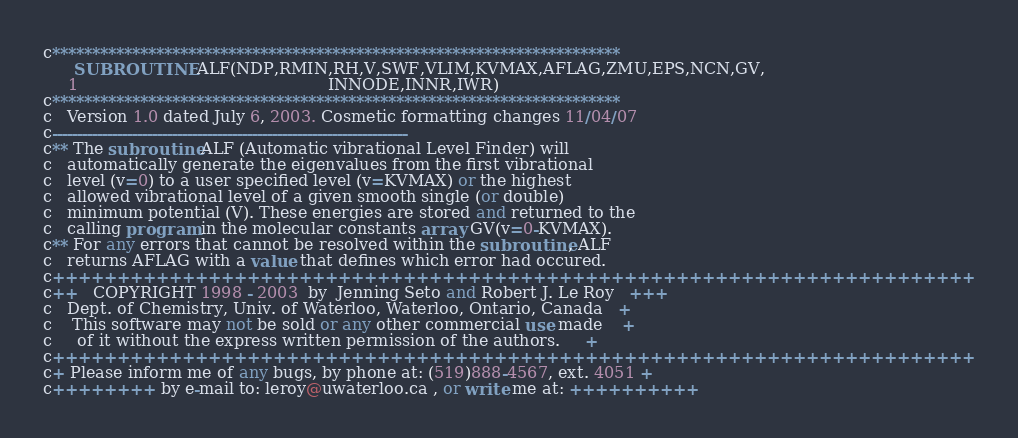Convert code to text. <code><loc_0><loc_0><loc_500><loc_500><_FORTRAN_>
c***********************************************************************
      SUBROUTINE ALF(NDP,RMIN,RH,V,SWF,VLIM,KVMAX,AFLAG,ZMU,EPS,NCN,GV,
     1                                                 INNODE,INNR,IWR)
c***********************************************************************
c   Version 1.0 dated July 6, 2003. Cosmetic formatting changes 11/04/07
c-----------------------------------------------------------------------
c** The subroutine ALF (Automatic vibrational Level Finder) will
c   automatically generate the eigenvalues from the first vibrational
c   level (v=0) to a user specified level (v=KVMAX) or the highest
c   allowed vibrational level of a given smooth single (or double)
c   minimum potential (V). These energies are stored and returned to the
c   calling program in the molecular constants array GV(v=0-KVMAX).
c** For any errors that cannot be resolved within the subroutine, ALF
c   returns AFLAG with a value that defines which error had occured.
c+++++++++++++++++++++++++++++++++++++++++++++++++++++++++++++++++++++++
c++   COPYRIGHT 1998 - 2003  by  Jenning Seto and Robert J. Le Roy   +++
c   Dept. of Chemistry, Univ. of Waterloo, Waterloo, Ontario, Canada   +
c    This software may not be sold or any other commercial use made    +
c     of it without the express written permission of the authors.     +
c+++++++++++++++++++++++++++++++++++++++++++++++++++++++++++++++++++++++
c+ Please inform me of any bugs, by phone at: (519)888-4567, ext. 4051 +
c++++++++ by e-mail to: leroy@uwaterloo.ca , or write me at: ++++++++++</code> 